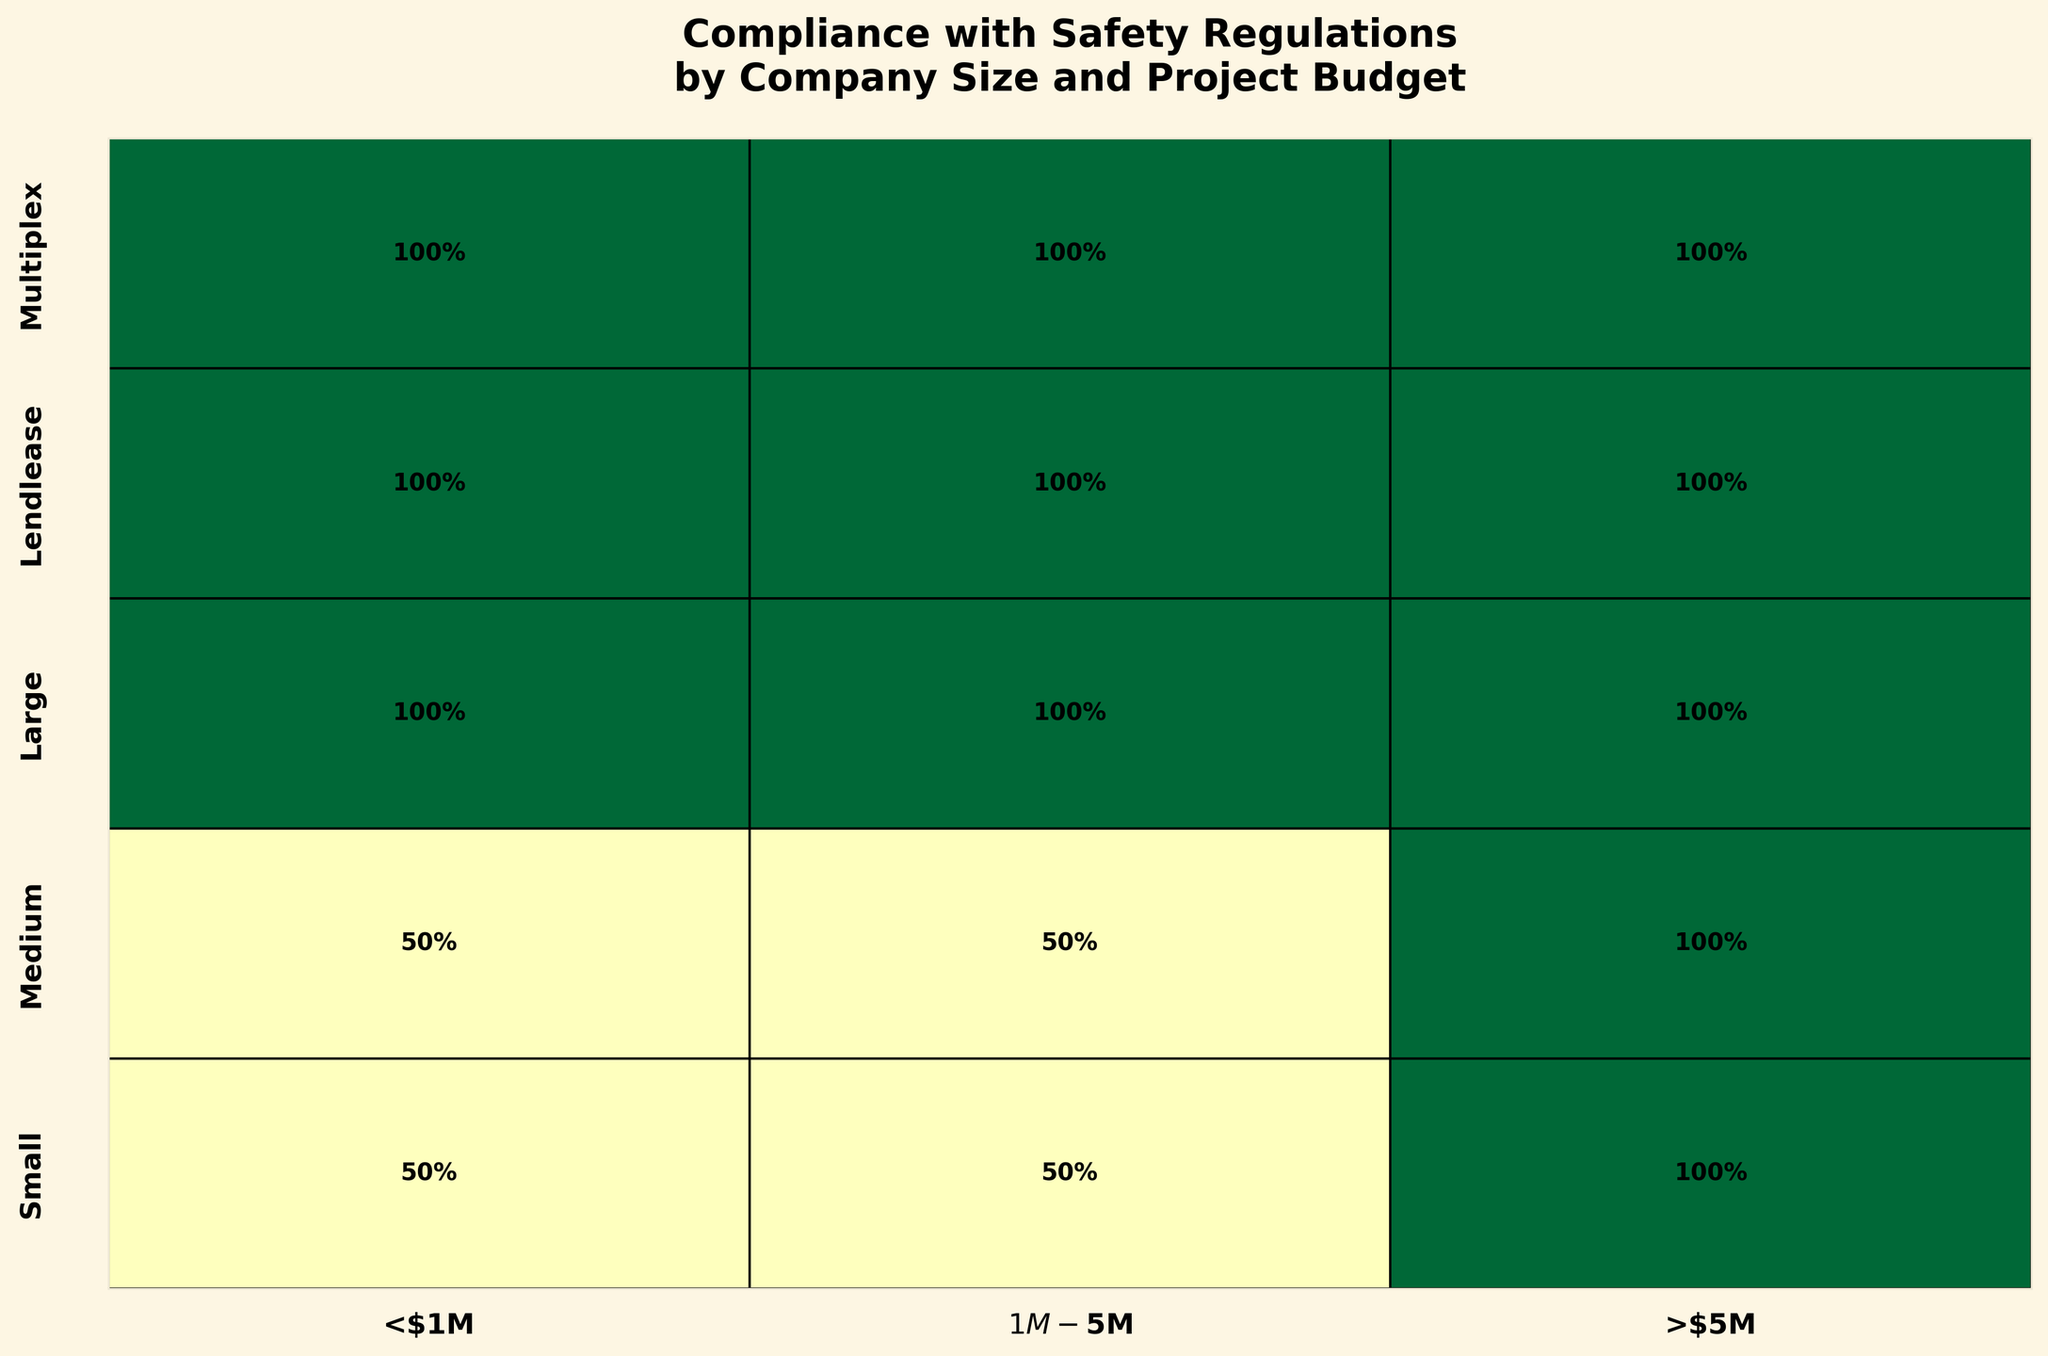What's the title of the plot? The title of the plot is shown at the top of the figure.
Answer: Compliance with Safety Regulations by Company Size and Project Budget Which company size has the highest compliance rate across all projects? To find this, look for the company size row where most or all rectangles are in a dark green shade, indicating higher compliance percentages.
Answer: Lendlease What percentage of Small companies comply fully with projects <$1M? Locate the "Small" row and the column for "<$1M," and read the percentage value inside the rectangle.
Answer: 50% How does the compliance rate for Medium companies with projects >$5M compare to Large companies with the same budget? Locate the "Medium" and "Large" rows, then the ">$5M" column, and compare the percentages inside the rectangles for these cells.
Answer: Medium companies 100%, Large companies 100% Are there any project budgets where Small companies never achieve full compliance? Check the "Small" row, and see if any of the rectangles are completely absent of percentage values or indicate 0%.
Answer: No What is the overall trend in compliance rates for Large companies across different project budgets? Observe the "Large" row to see if the compliance percentages increase, decrease, or stay constant across the "<$1M", "$1M-$5M", and ">$5M" columns.
Answer: 100% compliance across all budgets Compare the compliance rates between Lendlease and Multiplex for projects with budgets between $1M and $5M. Locate the "Lendlease" and "Multiplex" rows and find the column labeled "$1M-$5M." Compare the percentages within these cells.
Answer: Both 100% What is the full compliance rate for Medium-sized companies for projects <$1M compared to Small-sized companies? Check the full compliance percentage for Medium companies in the "<$1M" column and do the same for Small companies.
Answer: Medium 50%, Small 50% Which project budget category shows the most variation in compliance rates among all company sizes? Compare the variation in percentage values across all rows for each budget category. Find the budget with the most differences.
Answer: <$1M Are there any company sizes that always achieve full compliance regardless of the project budget? Look for any rows that have 100% compliance values in all of their rectangles.
Answer: Lendlease and Multiplex 